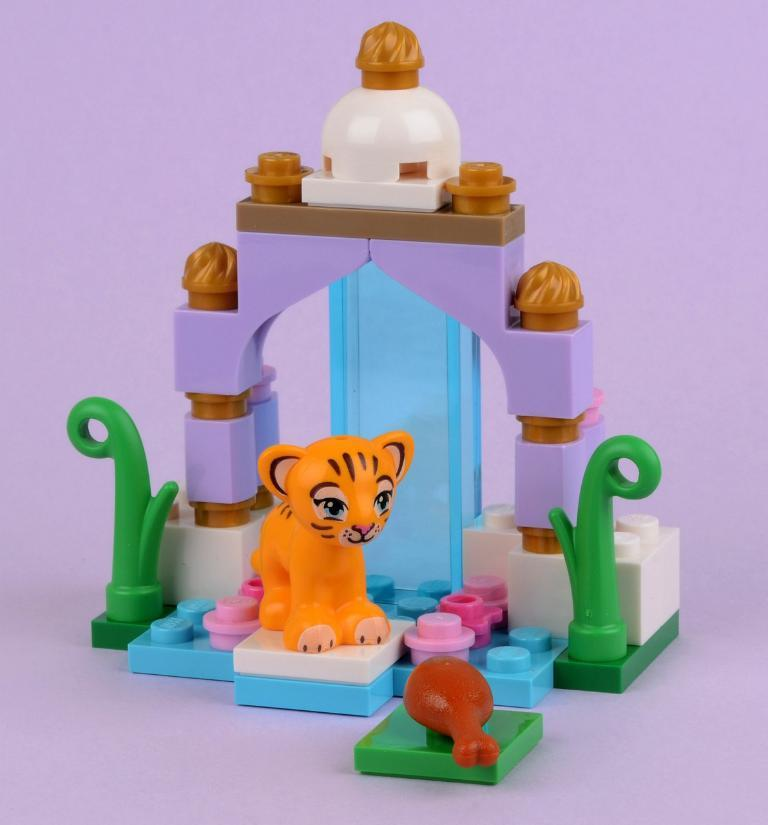What type of objects can be seen in the image? There are toys present in the image. What type of thread is used to create the texture of the toys in the image? There is no information about the type of thread or texture used in the toys, as the provided fact only mentions that there are toys present in the image. 